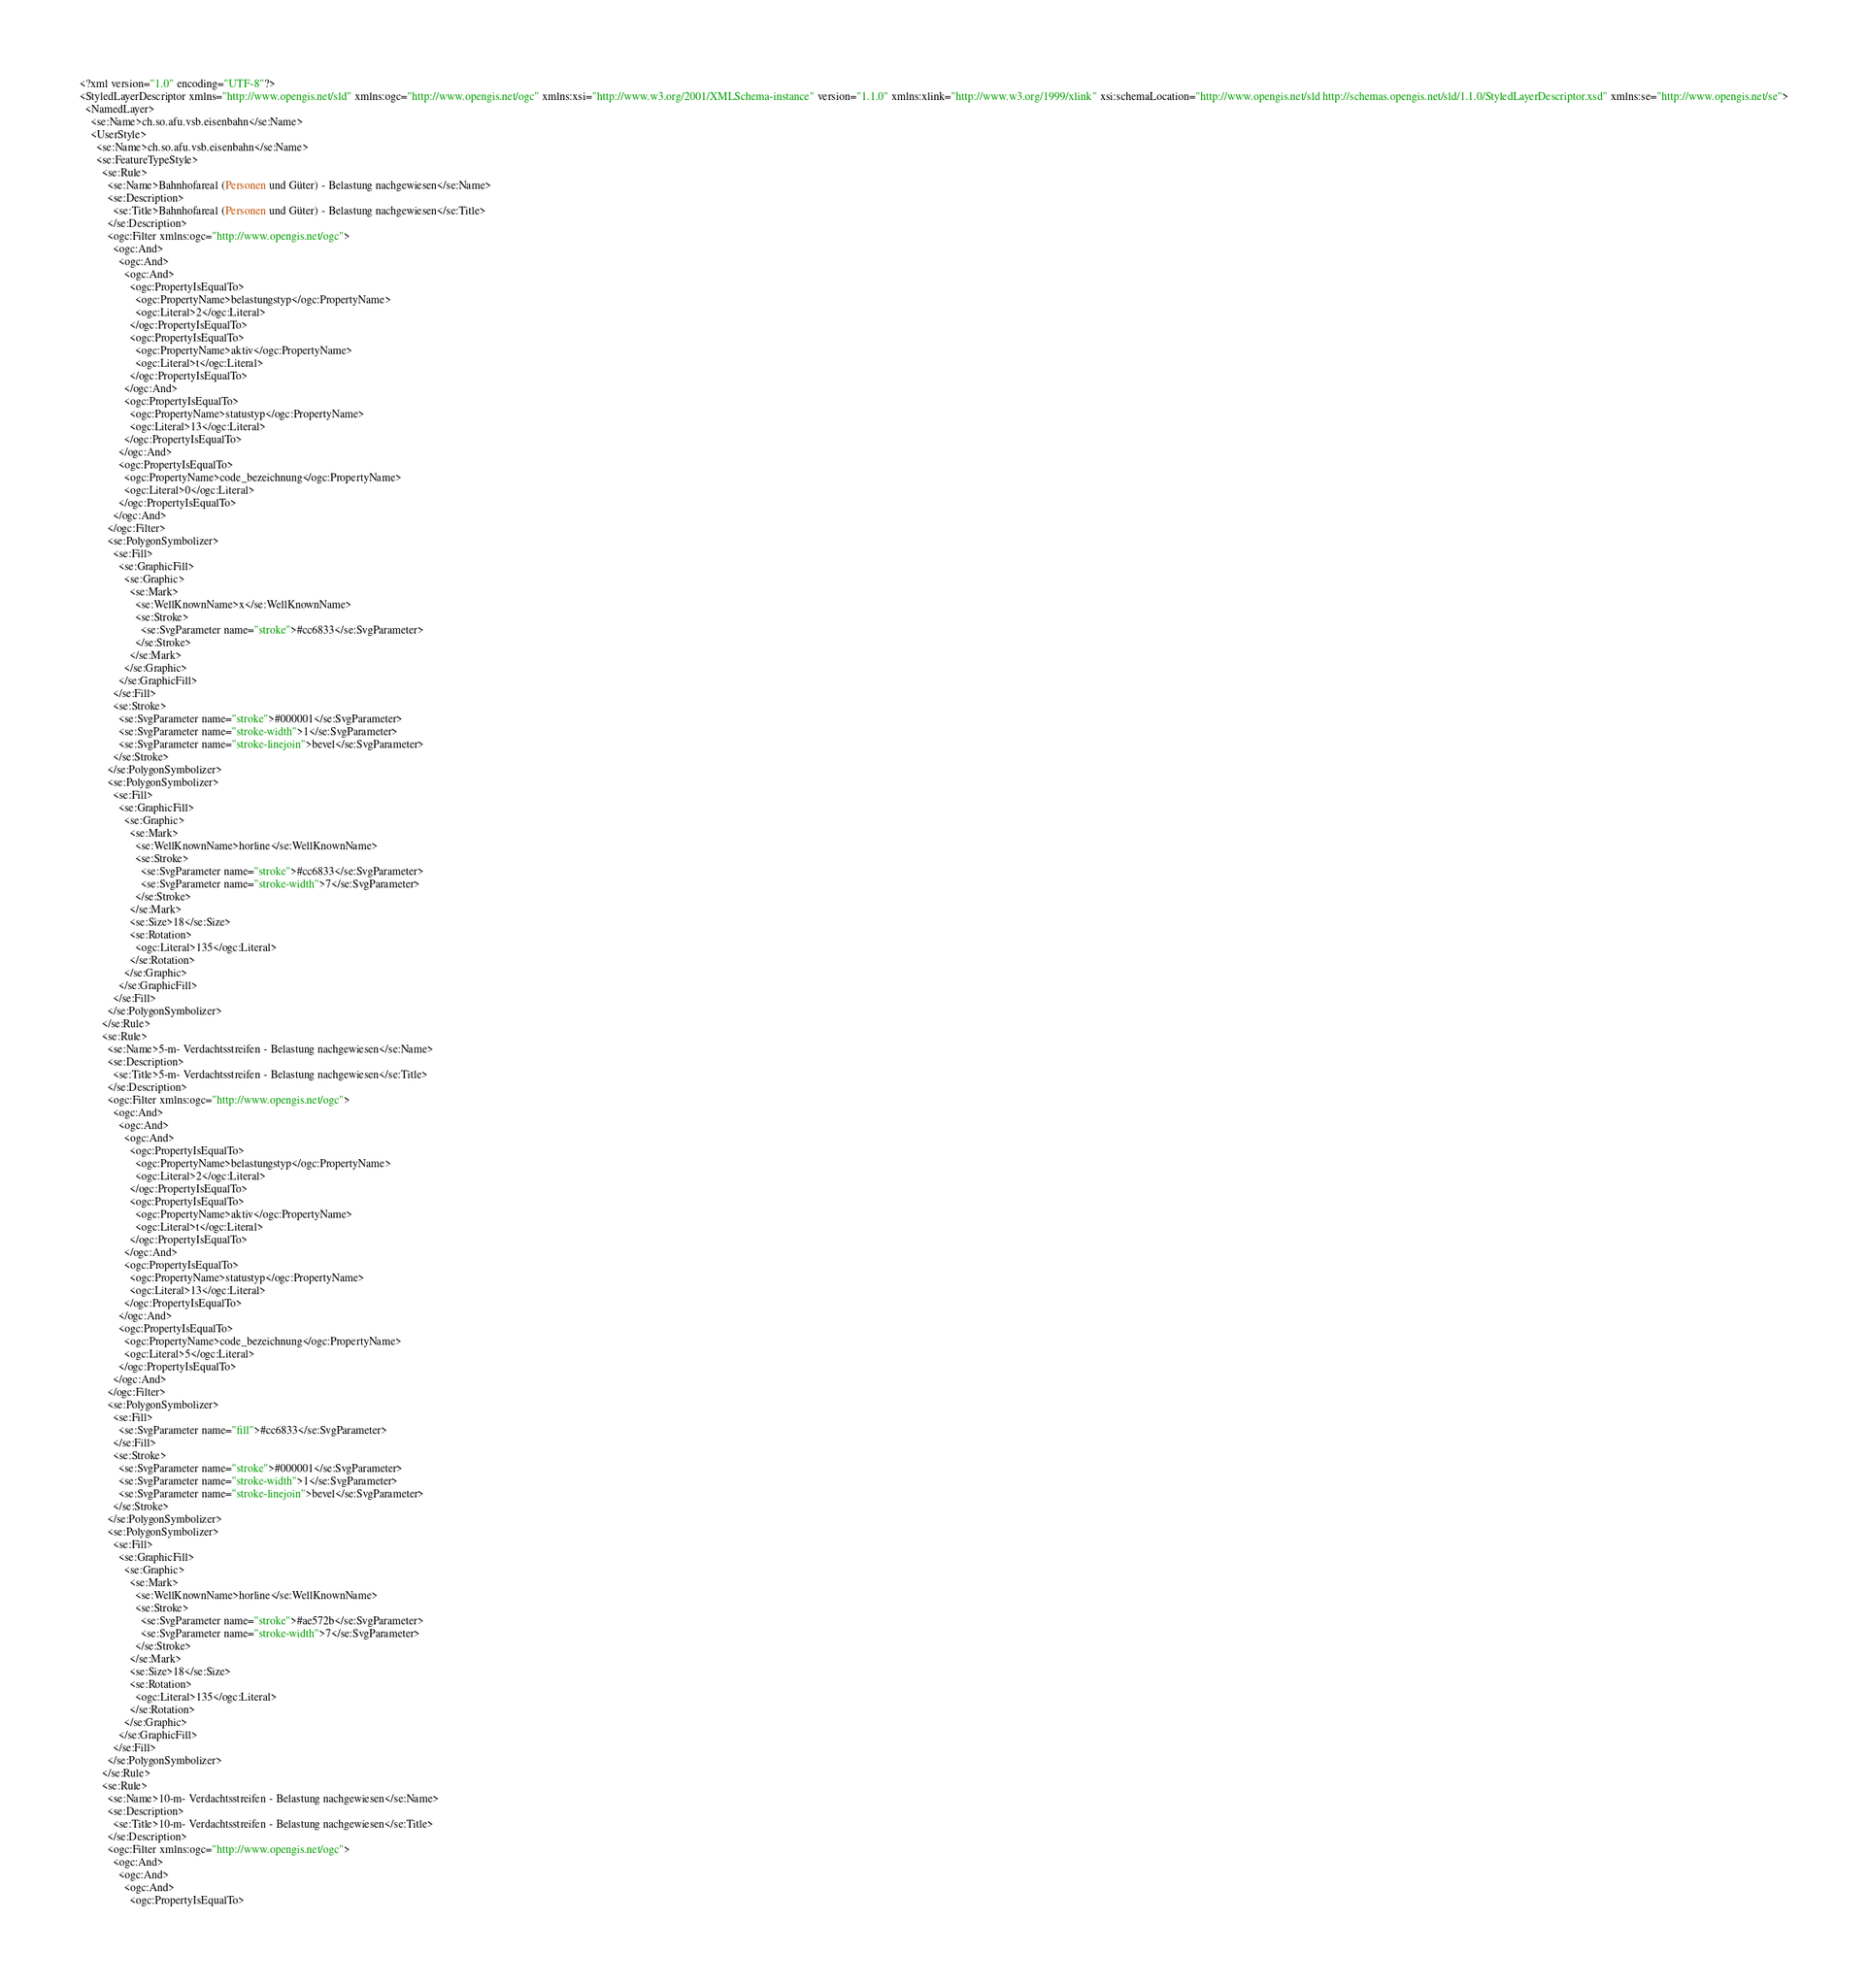Convert code to text. <code><loc_0><loc_0><loc_500><loc_500><_Scheme_><?xml version="1.0" encoding="UTF-8"?>
<StyledLayerDescriptor xmlns="http://www.opengis.net/sld" xmlns:ogc="http://www.opengis.net/ogc" xmlns:xsi="http://www.w3.org/2001/XMLSchema-instance" version="1.1.0" xmlns:xlink="http://www.w3.org/1999/xlink" xsi:schemaLocation="http://www.opengis.net/sld http://schemas.opengis.net/sld/1.1.0/StyledLayerDescriptor.xsd" xmlns:se="http://www.opengis.net/se">
  <NamedLayer>
    <se:Name>ch.so.afu.vsb.eisenbahn</se:Name>
    <UserStyle>
      <se:Name>ch.so.afu.vsb.eisenbahn</se:Name>
      <se:FeatureTypeStyle>
        <se:Rule>
          <se:Name>Bahnhofareal (Personen und Güter) - Belastung nachgewiesen</se:Name>
          <se:Description>
            <se:Title>Bahnhofareal (Personen und Güter) - Belastung nachgewiesen</se:Title>
          </se:Description>
          <ogc:Filter xmlns:ogc="http://www.opengis.net/ogc">
            <ogc:And>
              <ogc:And>
                <ogc:And>
                  <ogc:PropertyIsEqualTo>
                    <ogc:PropertyName>belastungstyp</ogc:PropertyName>
                    <ogc:Literal>2</ogc:Literal>
                  </ogc:PropertyIsEqualTo>
                  <ogc:PropertyIsEqualTo>
                    <ogc:PropertyName>aktiv</ogc:PropertyName>
                    <ogc:Literal>t</ogc:Literal>
                  </ogc:PropertyIsEqualTo>
                </ogc:And>
                <ogc:PropertyIsEqualTo>
                  <ogc:PropertyName>statustyp</ogc:PropertyName>
                  <ogc:Literal>13</ogc:Literal>
                </ogc:PropertyIsEqualTo>
              </ogc:And>
              <ogc:PropertyIsEqualTo>
                <ogc:PropertyName>code_bezeichnung</ogc:PropertyName>
                <ogc:Literal>0</ogc:Literal>
              </ogc:PropertyIsEqualTo>
            </ogc:And>
          </ogc:Filter>
          <se:PolygonSymbolizer>
            <se:Fill>
              <se:GraphicFill>
                <se:Graphic>
                  <se:Mark>
                    <se:WellKnownName>x</se:WellKnownName>
                    <se:Stroke>
                      <se:SvgParameter name="stroke">#cc6833</se:SvgParameter>
                    </se:Stroke>
                  </se:Mark>
                </se:Graphic>
              </se:GraphicFill>
            </se:Fill>
            <se:Stroke>
              <se:SvgParameter name="stroke">#000001</se:SvgParameter>
              <se:SvgParameter name="stroke-width">1</se:SvgParameter>
              <se:SvgParameter name="stroke-linejoin">bevel</se:SvgParameter>
            </se:Stroke>
          </se:PolygonSymbolizer>
          <se:PolygonSymbolizer>
            <se:Fill>
              <se:GraphicFill>
                <se:Graphic>
                  <se:Mark>
                    <se:WellKnownName>horline</se:WellKnownName>
                    <se:Stroke>
                      <se:SvgParameter name="stroke">#cc6833</se:SvgParameter>
                      <se:SvgParameter name="stroke-width">7</se:SvgParameter>
                    </se:Stroke>
                  </se:Mark>
                  <se:Size>18</se:Size>
                  <se:Rotation>
                    <ogc:Literal>135</ogc:Literal>
                  </se:Rotation>
                </se:Graphic>
              </se:GraphicFill>
            </se:Fill>
          </se:PolygonSymbolizer>
        </se:Rule>
        <se:Rule>
          <se:Name>5-m- Verdachtsstreifen - Belastung nachgewiesen</se:Name>
          <se:Description>
            <se:Title>5-m- Verdachtsstreifen - Belastung nachgewiesen</se:Title>
          </se:Description>
          <ogc:Filter xmlns:ogc="http://www.opengis.net/ogc">
            <ogc:And>
              <ogc:And>
                <ogc:And>
                  <ogc:PropertyIsEqualTo>
                    <ogc:PropertyName>belastungstyp</ogc:PropertyName>
                    <ogc:Literal>2</ogc:Literal>
                  </ogc:PropertyIsEqualTo>
                  <ogc:PropertyIsEqualTo>
                    <ogc:PropertyName>aktiv</ogc:PropertyName>
                    <ogc:Literal>t</ogc:Literal>
                  </ogc:PropertyIsEqualTo>
                </ogc:And>
                <ogc:PropertyIsEqualTo>
                  <ogc:PropertyName>statustyp</ogc:PropertyName>
                  <ogc:Literal>13</ogc:Literal>
                </ogc:PropertyIsEqualTo>
              </ogc:And>
              <ogc:PropertyIsEqualTo>
                <ogc:PropertyName>code_bezeichnung</ogc:PropertyName>
                <ogc:Literal>5</ogc:Literal>
              </ogc:PropertyIsEqualTo>
            </ogc:And>
          </ogc:Filter>
          <se:PolygonSymbolizer>
            <se:Fill>
              <se:SvgParameter name="fill">#cc6833</se:SvgParameter>
            </se:Fill>
            <se:Stroke>
              <se:SvgParameter name="stroke">#000001</se:SvgParameter>
              <se:SvgParameter name="stroke-width">1</se:SvgParameter>
              <se:SvgParameter name="stroke-linejoin">bevel</se:SvgParameter>
            </se:Stroke>
          </se:PolygonSymbolizer>
          <se:PolygonSymbolizer>
            <se:Fill>
              <se:GraphicFill>
                <se:Graphic>
                  <se:Mark>
                    <se:WellKnownName>horline</se:WellKnownName>
                    <se:Stroke>
                      <se:SvgParameter name="stroke">#ae572b</se:SvgParameter>
                      <se:SvgParameter name="stroke-width">7</se:SvgParameter>
                    </se:Stroke>
                  </se:Mark>
                  <se:Size>18</se:Size>
                  <se:Rotation>
                    <ogc:Literal>135</ogc:Literal>
                  </se:Rotation>
                </se:Graphic>
              </se:GraphicFill>
            </se:Fill>
          </se:PolygonSymbolizer>
        </se:Rule>
        <se:Rule>
          <se:Name>10-m- Verdachtsstreifen - Belastung nachgewiesen</se:Name>
          <se:Description>
            <se:Title>10-m- Verdachtsstreifen - Belastung nachgewiesen</se:Title>
          </se:Description>
          <ogc:Filter xmlns:ogc="http://www.opengis.net/ogc">
            <ogc:And>
              <ogc:And>
                <ogc:And>
                  <ogc:PropertyIsEqualTo></code> 